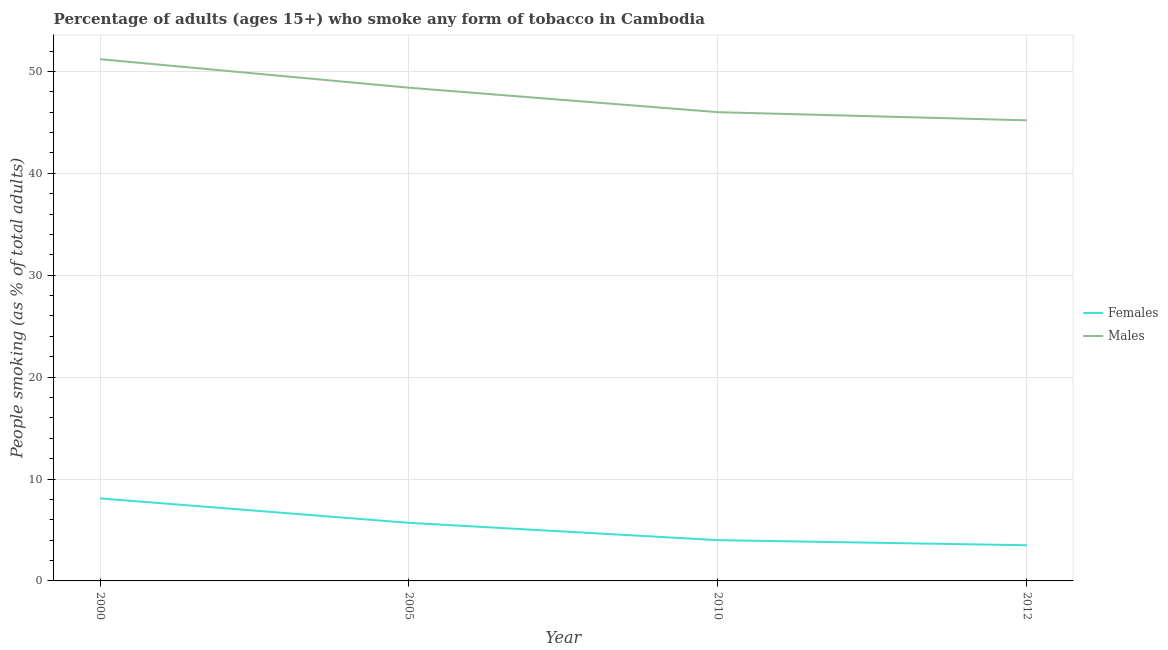How many different coloured lines are there?
Your answer should be compact. 2. Across all years, what is the maximum percentage of males who smoke?
Ensure brevity in your answer.  51.2. In which year was the percentage of females who smoke maximum?
Make the answer very short. 2000. What is the total percentage of males who smoke in the graph?
Offer a terse response. 190.8. What is the difference between the percentage of males who smoke in 2000 and that in 2005?
Your answer should be very brief. 2.8. What is the difference between the percentage of males who smoke in 2005 and the percentage of females who smoke in 2010?
Your answer should be very brief. 44.4. What is the average percentage of males who smoke per year?
Your response must be concise. 47.7. In the year 2012, what is the difference between the percentage of males who smoke and percentage of females who smoke?
Provide a short and direct response. 41.7. What is the ratio of the percentage of males who smoke in 2000 to that in 2010?
Keep it short and to the point. 1.11. Is the difference between the percentage of males who smoke in 2000 and 2010 greater than the difference between the percentage of females who smoke in 2000 and 2010?
Your answer should be very brief. Yes. What is the difference between the highest and the second highest percentage of females who smoke?
Your response must be concise. 2.4. Is the sum of the percentage of females who smoke in 2000 and 2012 greater than the maximum percentage of males who smoke across all years?
Ensure brevity in your answer.  No. Does the percentage of females who smoke monotonically increase over the years?
Keep it short and to the point. No. Is the percentage of females who smoke strictly less than the percentage of males who smoke over the years?
Ensure brevity in your answer.  Yes. What is the difference between two consecutive major ticks on the Y-axis?
Your answer should be compact. 10. Are the values on the major ticks of Y-axis written in scientific E-notation?
Your answer should be very brief. No. Does the graph contain grids?
Your answer should be very brief. Yes. How are the legend labels stacked?
Your answer should be very brief. Vertical. What is the title of the graph?
Provide a succinct answer. Percentage of adults (ages 15+) who smoke any form of tobacco in Cambodia. What is the label or title of the Y-axis?
Provide a succinct answer. People smoking (as % of total adults). What is the People smoking (as % of total adults) of Males in 2000?
Your response must be concise. 51.2. What is the People smoking (as % of total adults) of Females in 2005?
Provide a short and direct response. 5.7. What is the People smoking (as % of total adults) in Males in 2005?
Give a very brief answer. 48.4. What is the People smoking (as % of total adults) of Females in 2010?
Offer a terse response. 4. What is the People smoking (as % of total adults) in Males in 2012?
Offer a very short reply. 45.2. Across all years, what is the maximum People smoking (as % of total adults) of Males?
Offer a terse response. 51.2. Across all years, what is the minimum People smoking (as % of total adults) in Females?
Your answer should be compact. 3.5. Across all years, what is the minimum People smoking (as % of total adults) of Males?
Ensure brevity in your answer.  45.2. What is the total People smoking (as % of total adults) of Females in the graph?
Your answer should be compact. 21.3. What is the total People smoking (as % of total adults) in Males in the graph?
Offer a terse response. 190.8. What is the difference between the People smoking (as % of total adults) in Females in 2000 and that in 2005?
Offer a terse response. 2.4. What is the difference between the People smoking (as % of total adults) of Males in 2000 and that in 2005?
Offer a terse response. 2.8. What is the difference between the People smoking (as % of total adults) in Males in 2000 and that in 2010?
Offer a very short reply. 5.2. What is the difference between the People smoking (as % of total adults) in Males in 2005 and that in 2010?
Your answer should be compact. 2.4. What is the difference between the People smoking (as % of total adults) in Males in 2005 and that in 2012?
Your response must be concise. 3.2. What is the difference between the People smoking (as % of total adults) of Males in 2010 and that in 2012?
Keep it short and to the point. 0.8. What is the difference between the People smoking (as % of total adults) of Females in 2000 and the People smoking (as % of total adults) of Males in 2005?
Offer a very short reply. -40.3. What is the difference between the People smoking (as % of total adults) in Females in 2000 and the People smoking (as % of total adults) in Males in 2010?
Your answer should be compact. -37.9. What is the difference between the People smoking (as % of total adults) in Females in 2000 and the People smoking (as % of total adults) in Males in 2012?
Your response must be concise. -37.1. What is the difference between the People smoking (as % of total adults) in Females in 2005 and the People smoking (as % of total adults) in Males in 2010?
Ensure brevity in your answer.  -40.3. What is the difference between the People smoking (as % of total adults) of Females in 2005 and the People smoking (as % of total adults) of Males in 2012?
Make the answer very short. -39.5. What is the difference between the People smoking (as % of total adults) of Females in 2010 and the People smoking (as % of total adults) of Males in 2012?
Your answer should be very brief. -41.2. What is the average People smoking (as % of total adults) in Females per year?
Provide a succinct answer. 5.33. What is the average People smoking (as % of total adults) of Males per year?
Ensure brevity in your answer.  47.7. In the year 2000, what is the difference between the People smoking (as % of total adults) of Females and People smoking (as % of total adults) of Males?
Your answer should be compact. -43.1. In the year 2005, what is the difference between the People smoking (as % of total adults) in Females and People smoking (as % of total adults) in Males?
Keep it short and to the point. -42.7. In the year 2010, what is the difference between the People smoking (as % of total adults) of Females and People smoking (as % of total adults) of Males?
Provide a succinct answer. -42. In the year 2012, what is the difference between the People smoking (as % of total adults) of Females and People smoking (as % of total adults) of Males?
Keep it short and to the point. -41.7. What is the ratio of the People smoking (as % of total adults) in Females in 2000 to that in 2005?
Provide a short and direct response. 1.42. What is the ratio of the People smoking (as % of total adults) in Males in 2000 to that in 2005?
Ensure brevity in your answer.  1.06. What is the ratio of the People smoking (as % of total adults) of Females in 2000 to that in 2010?
Provide a succinct answer. 2.02. What is the ratio of the People smoking (as % of total adults) of Males in 2000 to that in 2010?
Ensure brevity in your answer.  1.11. What is the ratio of the People smoking (as % of total adults) in Females in 2000 to that in 2012?
Provide a short and direct response. 2.31. What is the ratio of the People smoking (as % of total adults) of Males in 2000 to that in 2012?
Make the answer very short. 1.13. What is the ratio of the People smoking (as % of total adults) of Females in 2005 to that in 2010?
Provide a short and direct response. 1.43. What is the ratio of the People smoking (as % of total adults) in Males in 2005 to that in 2010?
Your answer should be compact. 1.05. What is the ratio of the People smoking (as % of total adults) of Females in 2005 to that in 2012?
Offer a terse response. 1.63. What is the ratio of the People smoking (as % of total adults) of Males in 2005 to that in 2012?
Make the answer very short. 1.07. What is the ratio of the People smoking (as % of total adults) in Females in 2010 to that in 2012?
Provide a succinct answer. 1.14. What is the ratio of the People smoking (as % of total adults) of Males in 2010 to that in 2012?
Give a very brief answer. 1.02. What is the difference between the highest and the second highest People smoking (as % of total adults) of Males?
Provide a short and direct response. 2.8. What is the difference between the highest and the lowest People smoking (as % of total adults) of Females?
Provide a succinct answer. 4.6. What is the difference between the highest and the lowest People smoking (as % of total adults) in Males?
Provide a succinct answer. 6. 